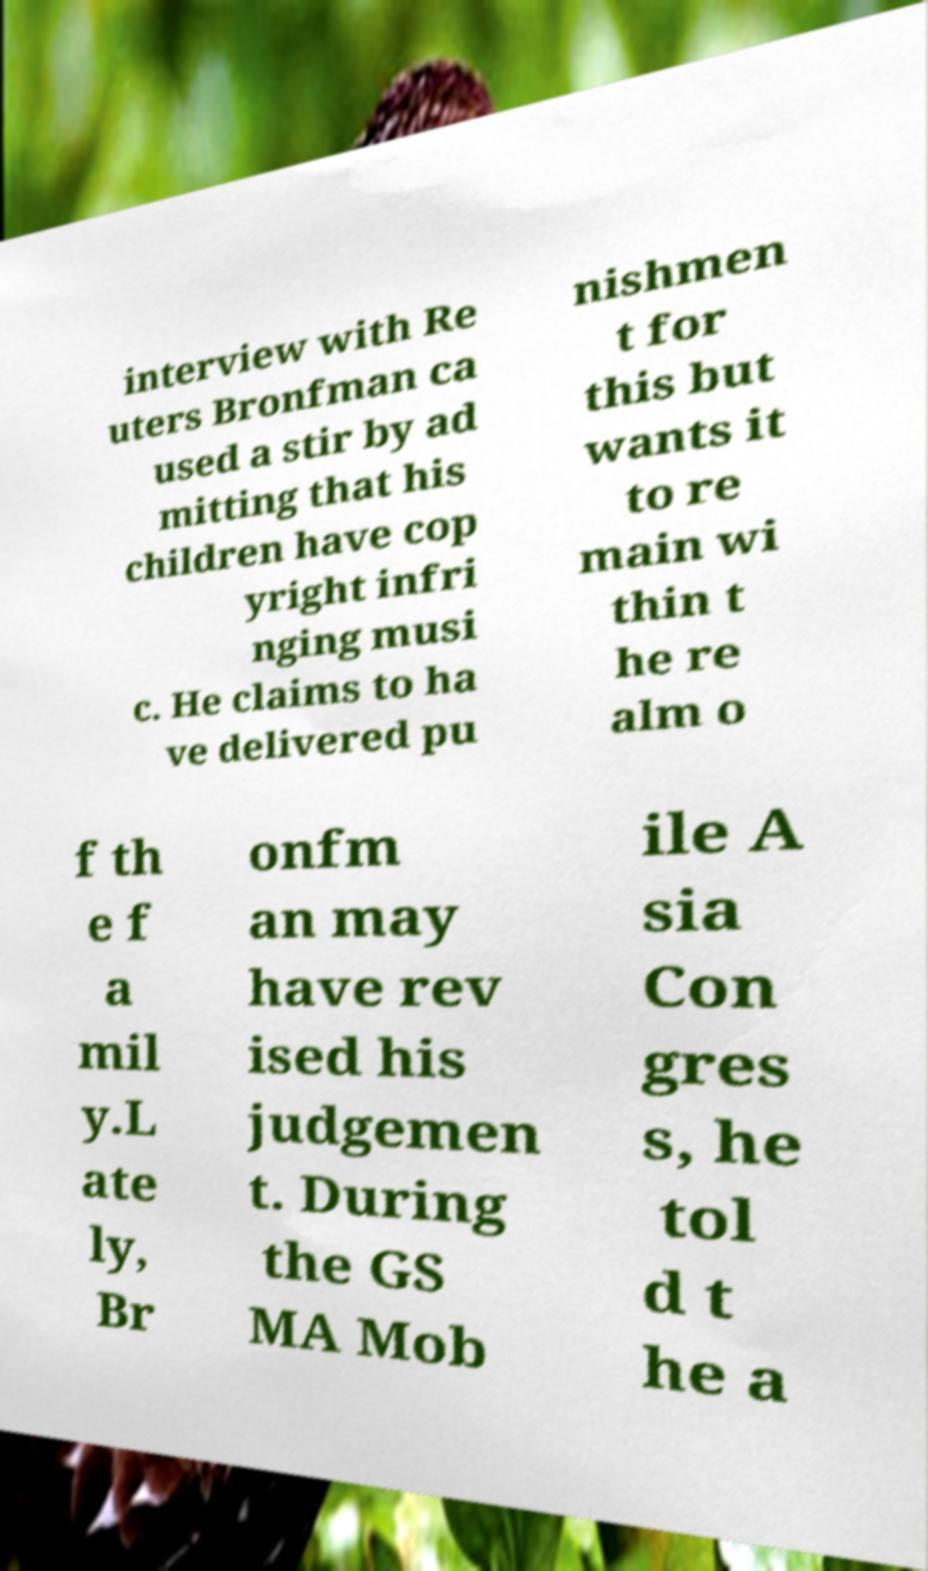Could you extract and type out the text from this image? interview with Re uters Bronfman ca used a stir by ad mitting that his children have cop yright infri nging musi c. He claims to ha ve delivered pu nishmen t for this but wants it to re main wi thin t he re alm o f th e f a mil y.L ate ly, Br onfm an may have rev ised his judgemen t. During the GS MA Mob ile A sia Con gres s, he tol d t he a 